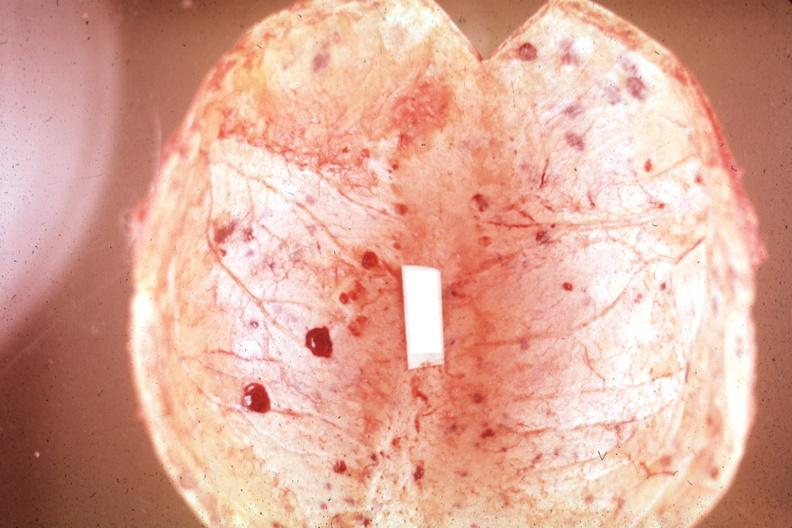does this image show not the best color in photo?
Answer the question using a single word or phrase. Yes 